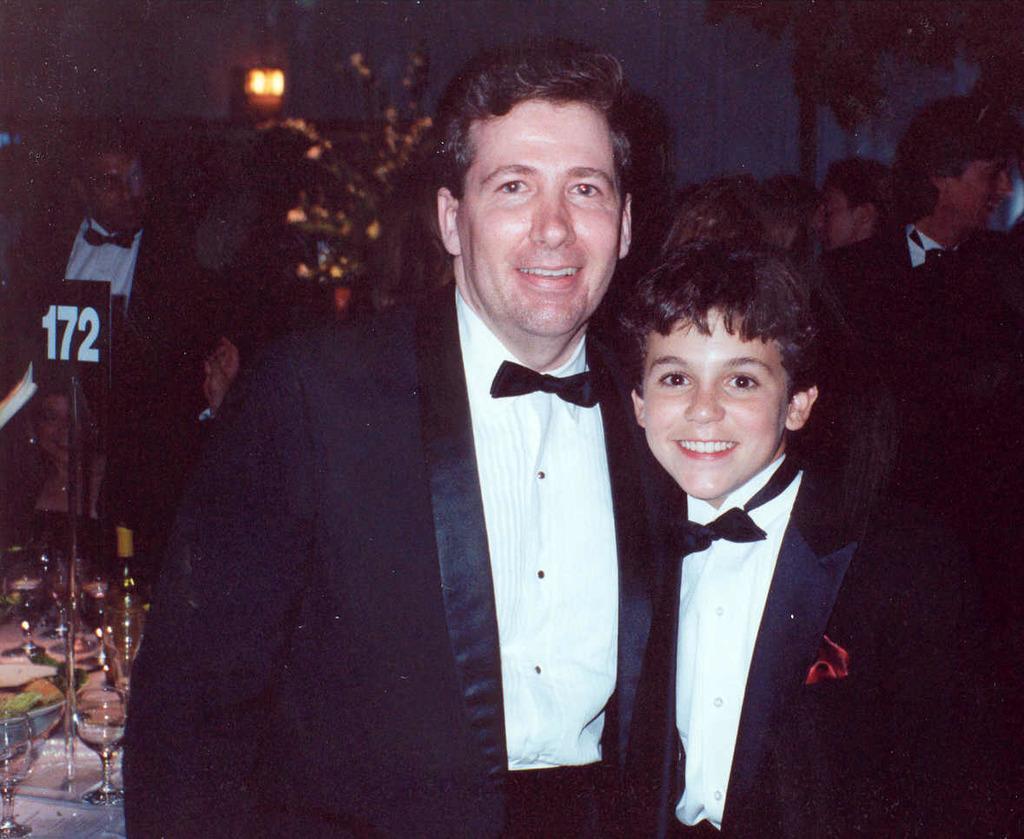Describe this image in one or two sentences. In this picture we can see a man and a boy wore blazers, bow ties and smiling and in the background we can see some people, glasses, bottle, light, trees. 